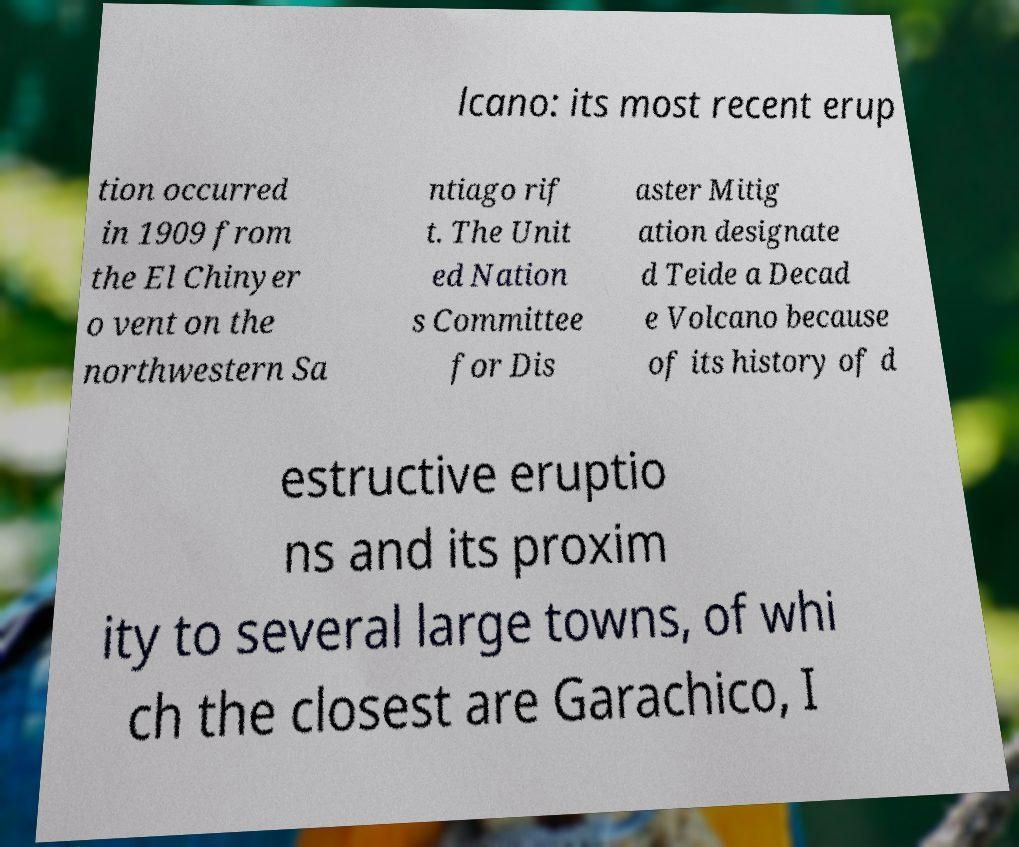Could you assist in decoding the text presented in this image and type it out clearly? lcano: its most recent erup tion occurred in 1909 from the El Chinyer o vent on the northwestern Sa ntiago rif t. The Unit ed Nation s Committee for Dis aster Mitig ation designate d Teide a Decad e Volcano because of its history of d estructive eruptio ns and its proxim ity to several large towns, of whi ch the closest are Garachico, I 